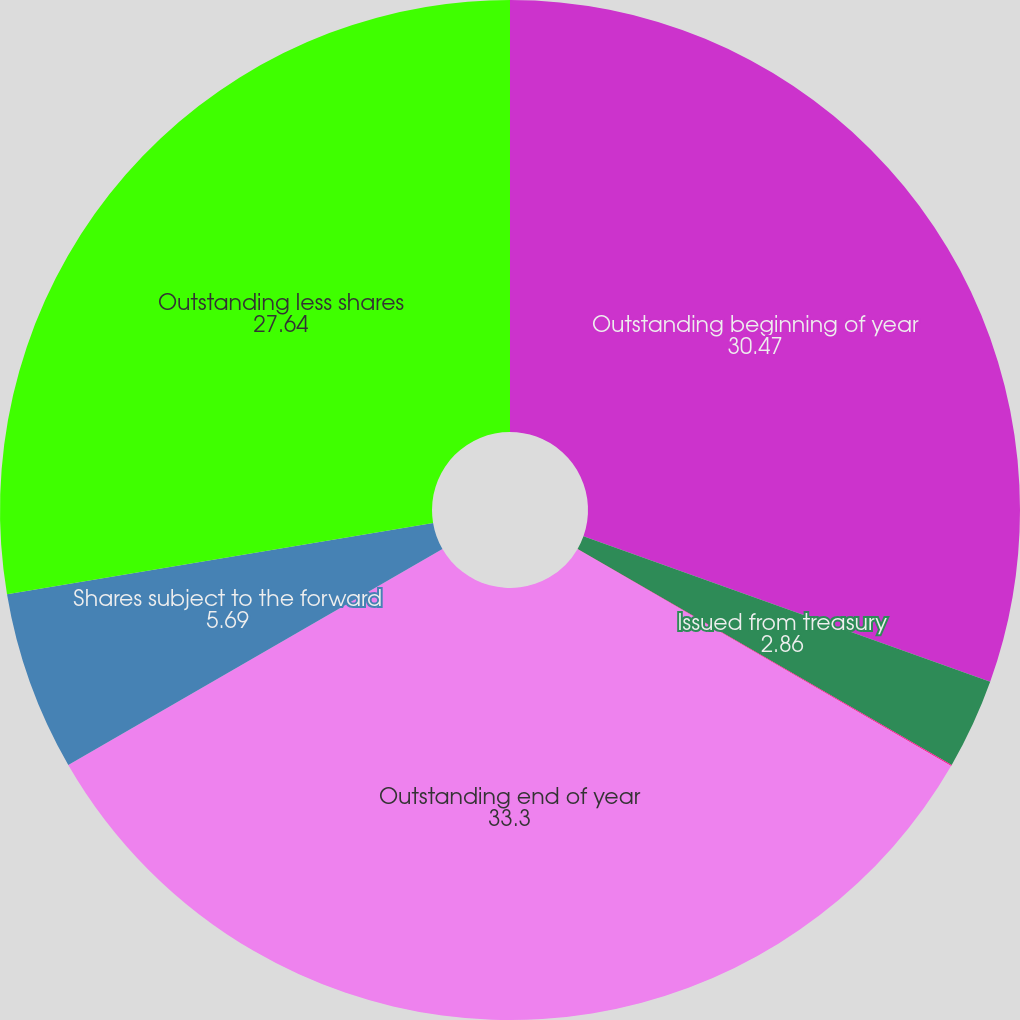<chart> <loc_0><loc_0><loc_500><loc_500><pie_chart><fcel>Outstanding beginning of year<fcel>Issued from treasury<fcel>Returned to treasury<fcel>Outstanding end of year<fcel>Shares subject to the forward<fcel>Outstanding less shares<nl><fcel>30.47%<fcel>2.86%<fcel>0.04%<fcel>33.3%<fcel>5.69%<fcel>27.64%<nl></chart> 